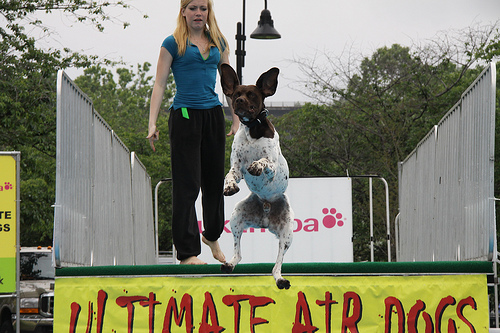<image>
Is there a dog behind the woman? No. The dog is not behind the woman. From this viewpoint, the dog appears to be positioned elsewhere in the scene. Is the dog above the ground? Yes. The dog is positioned above the ground in the vertical space, higher up in the scene. 